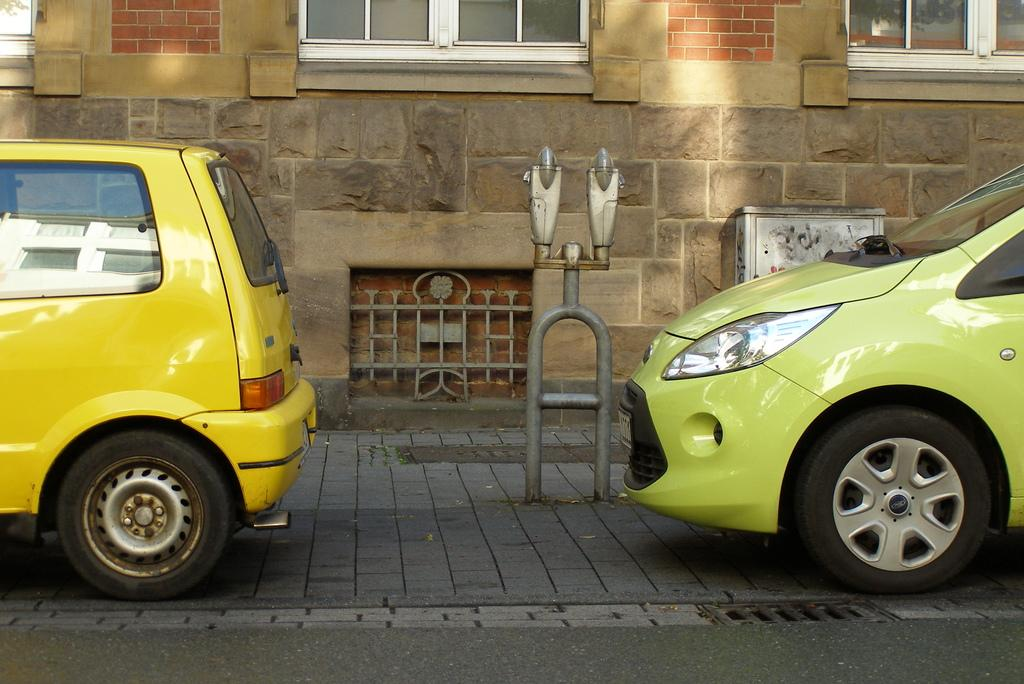How many vehicles can be seen on the road in the image? There are two vehicles on the road in the image. What is the object that resembles a light pole in the image? There is an object that looks like a light pole in the image. What can be seen in the background of the image? There is a building in the background of the image. Can you tell me how many theories are being discussed on the sofa in the image? There is no sofa present in the image, and therefore no theories being discussed. What type of scale is used to weigh the object on the light pole in the image? There is no object being weighed on the light pole in the image, and no scale is present. 